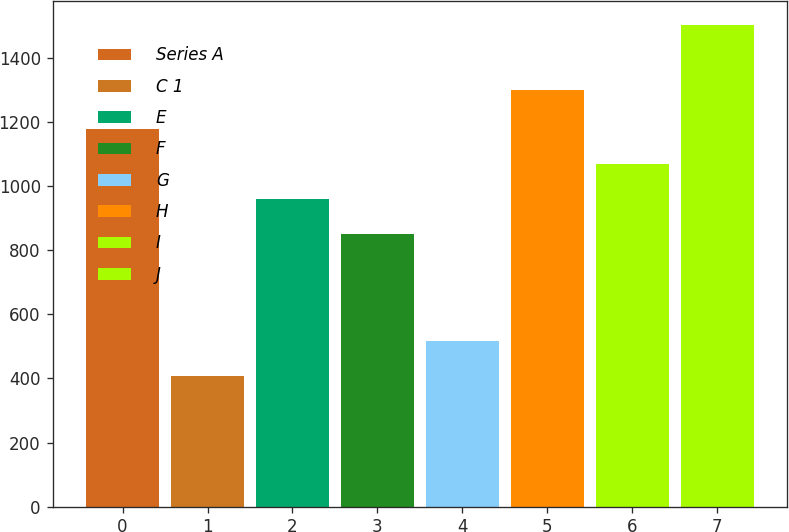<chart> <loc_0><loc_0><loc_500><loc_500><bar_chart><fcel>Series A<fcel>C 1<fcel>E<fcel>F<fcel>G<fcel>H<fcel>I<fcel>J<nl><fcel>1177.6<fcel>408<fcel>959.2<fcel>850<fcel>517.2<fcel>1300<fcel>1068.4<fcel>1500<nl></chart> 